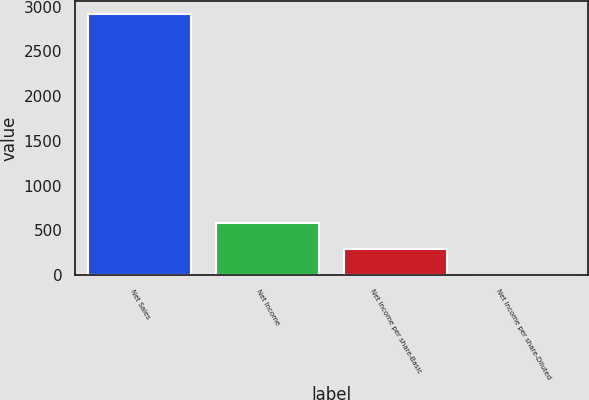Convert chart. <chart><loc_0><loc_0><loc_500><loc_500><bar_chart><fcel>Net Sales<fcel>Net Income<fcel>Net Income per share-Basic<fcel>Net Income per share-Diluted<nl><fcel>2921.9<fcel>586.35<fcel>294.4<fcel>2.45<nl></chart> 